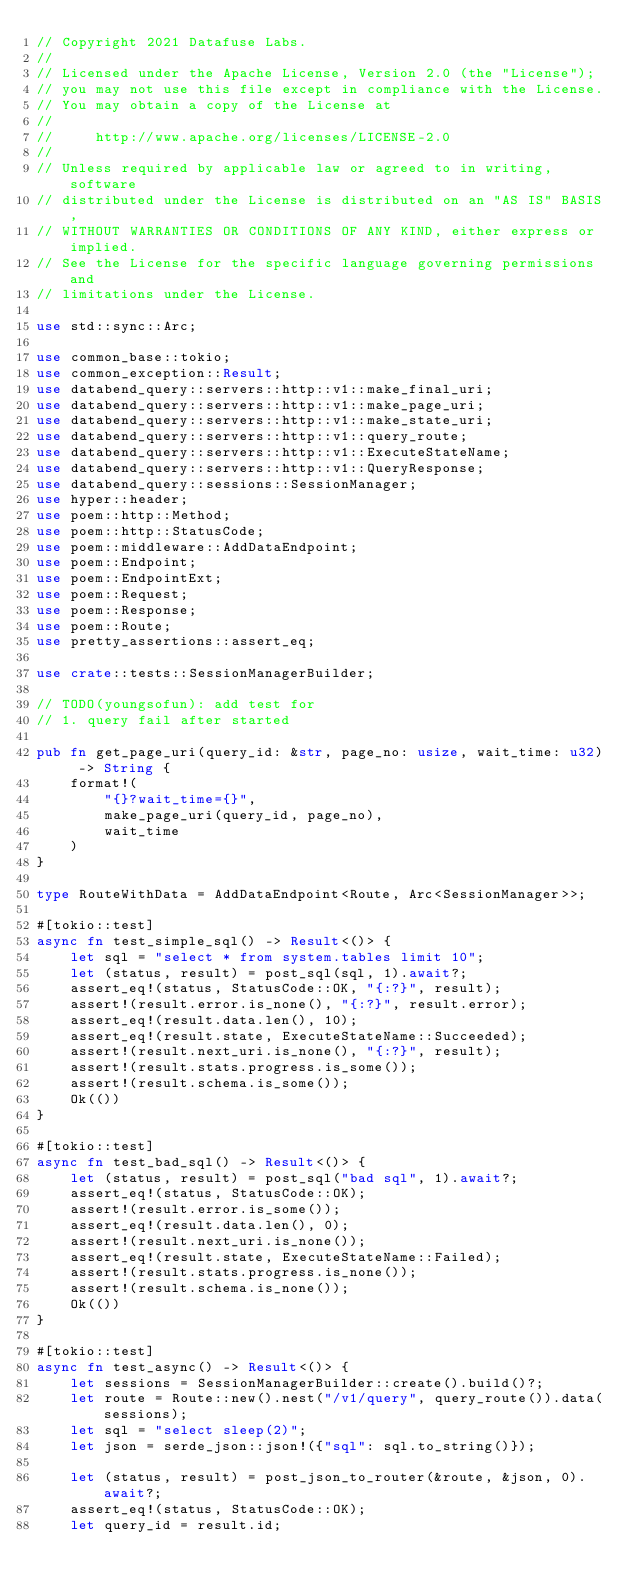<code> <loc_0><loc_0><loc_500><loc_500><_Rust_>// Copyright 2021 Datafuse Labs.
//
// Licensed under the Apache License, Version 2.0 (the "License");
// you may not use this file except in compliance with the License.
// You may obtain a copy of the License at
//
//     http://www.apache.org/licenses/LICENSE-2.0
//
// Unless required by applicable law or agreed to in writing, software
// distributed under the License is distributed on an "AS IS" BASIS,
// WITHOUT WARRANTIES OR CONDITIONS OF ANY KIND, either express or implied.
// See the License for the specific language governing permissions and
// limitations under the License.

use std::sync::Arc;

use common_base::tokio;
use common_exception::Result;
use databend_query::servers::http::v1::make_final_uri;
use databend_query::servers::http::v1::make_page_uri;
use databend_query::servers::http::v1::make_state_uri;
use databend_query::servers::http::v1::query_route;
use databend_query::servers::http::v1::ExecuteStateName;
use databend_query::servers::http::v1::QueryResponse;
use databend_query::sessions::SessionManager;
use hyper::header;
use poem::http::Method;
use poem::http::StatusCode;
use poem::middleware::AddDataEndpoint;
use poem::Endpoint;
use poem::EndpointExt;
use poem::Request;
use poem::Response;
use poem::Route;
use pretty_assertions::assert_eq;

use crate::tests::SessionManagerBuilder;

// TODO(youngsofun): add test for
// 1. query fail after started

pub fn get_page_uri(query_id: &str, page_no: usize, wait_time: u32) -> String {
    format!(
        "{}?wait_time={}",
        make_page_uri(query_id, page_no),
        wait_time
    )
}

type RouteWithData = AddDataEndpoint<Route, Arc<SessionManager>>;

#[tokio::test]
async fn test_simple_sql() -> Result<()> {
    let sql = "select * from system.tables limit 10";
    let (status, result) = post_sql(sql, 1).await?;
    assert_eq!(status, StatusCode::OK, "{:?}", result);
    assert!(result.error.is_none(), "{:?}", result.error);
    assert_eq!(result.data.len(), 10);
    assert_eq!(result.state, ExecuteStateName::Succeeded);
    assert!(result.next_uri.is_none(), "{:?}", result);
    assert!(result.stats.progress.is_some());
    assert!(result.schema.is_some());
    Ok(())
}

#[tokio::test]
async fn test_bad_sql() -> Result<()> {
    let (status, result) = post_sql("bad sql", 1).await?;
    assert_eq!(status, StatusCode::OK);
    assert!(result.error.is_some());
    assert_eq!(result.data.len(), 0);
    assert!(result.next_uri.is_none());
    assert_eq!(result.state, ExecuteStateName::Failed);
    assert!(result.stats.progress.is_none());
    assert!(result.schema.is_none());
    Ok(())
}

#[tokio::test]
async fn test_async() -> Result<()> {
    let sessions = SessionManagerBuilder::create().build()?;
    let route = Route::new().nest("/v1/query", query_route()).data(sessions);
    let sql = "select sleep(2)";
    let json = serde_json::json!({"sql": sql.to_string()});

    let (status, result) = post_json_to_router(&route, &json, 0).await?;
    assert_eq!(status, StatusCode::OK);
    let query_id = result.id;</code> 